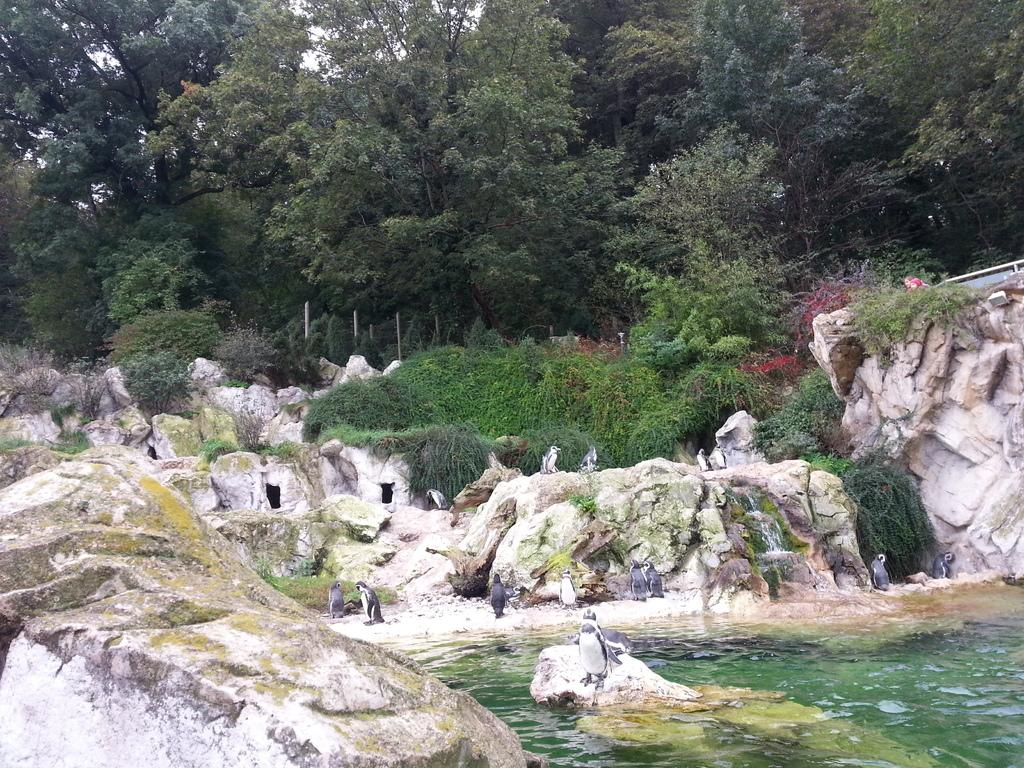What is located in the front of the image? There is water in the front of the image. What animals are in the center of the image? There are penguins in the center of the image. What type of vegetation can be seen in the background of the image? There are plants and trees in the background of the image. What other creatures are present in the background of the image? There are moles in the background of the image. How many girls are playing with the hydrant in the image? There are no girls or hydrants present in the image. What form does the water take in the image? The water is not depicted in a specific form in the image; it is simply visible in the front. 